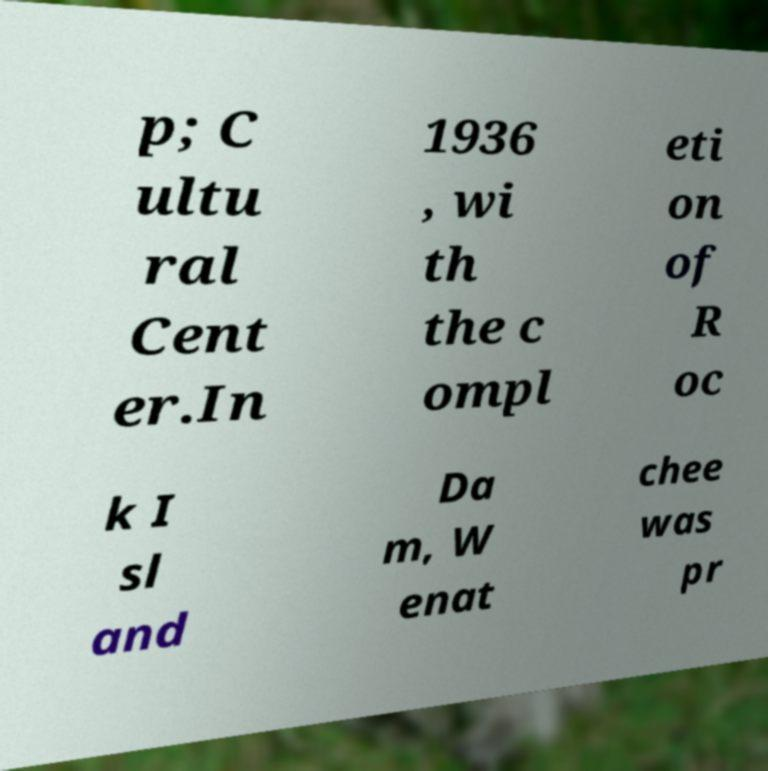Can you read and provide the text displayed in the image?This photo seems to have some interesting text. Can you extract and type it out for me? p; C ultu ral Cent er.In 1936 , wi th the c ompl eti on of R oc k I sl and Da m, W enat chee was pr 